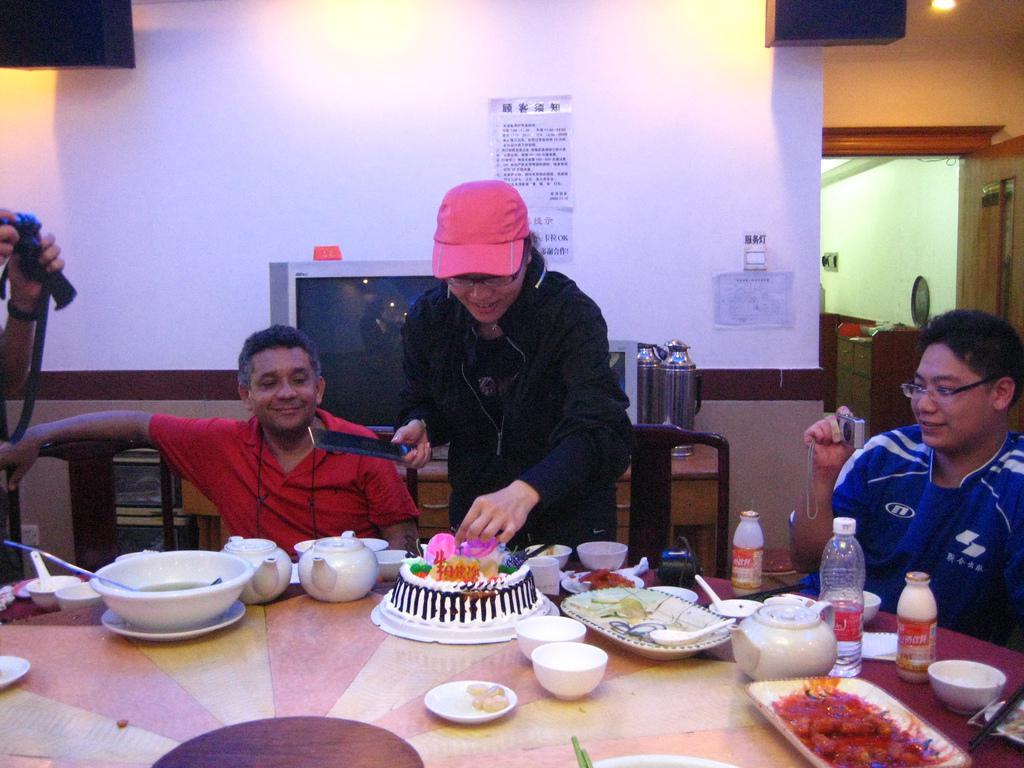Question: where is everyone gathered?
Choices:
A. In the car.
B. At the table.
C. On top of the house.
D. In the yard.
Answer with the letter. Answer: B Question: why are they at the table?
Choices:
A. It's meal time.
B. It's time to talk.
C. It's reading time.
D. It's time to play.
Answer with the letter. Answer: A Question: what is the color of the shirt of the man closest to the man in the pink hat?
Choices:
A. Blue.
B. Green.
C. Yellow.
D. Red.
Answer with the letter. Answer: D Question: when will the people leave the table?
Choices:
A. When the meeting is over.
B. At the end of the day.
C. In an hour.
D. When they are done eating.
Answer with the letter. Answer: D Question: what is the pattern of the table?
Choices:
A. Plaid.
B. Diamond.
C. Paisley.
D. It has a pattern of rays.
Answer with the letter. Answer: D Question: what is the number of people with glasses?
Choices:
A. Two.
B. Five.
C. Fifteen.
D. Nine.
Answer with the letter. Answer: A Question: where is everyone?
Choices:
A. At the house.
B. At the school.
C. At a table.
D. At the mall.
Answer with the letter. Answer: C Question: where is a starburst design?
Choices:
A. On the table cloth.
B. In the kitchen.
C. In the home.
D. In the table.
Answer with the letter. Answer: D Question: who is wearing a pink hat?
Choices:
A. The child.
B. The grandmother.
C. The woman.
D. The dancer.
Answer with the letter. Answer: C Question: who is wearing the red cap?
Choices:
A. The kitten.
B. The dog.
C. The woman.
D. The child.
Answer with the letter. Answer: C Question: what in the background is off?
Choices:
A. A computer.
B. A clock.
C. A television.
D. A cell phone.
Answer with the letter. Answer: C Question: what is in the ladies hand?
Choices:
A. A knife.
B. A purse.
C. A handkerchief.
D. A baton.
Answer with the letter. Answer: A Question: who's shirt is orange?
Choices:
A. The woman on the right.
B. The man on the left.
C. The man in front.
D. The woman in the back.
Answer with the letter. Answer: B 